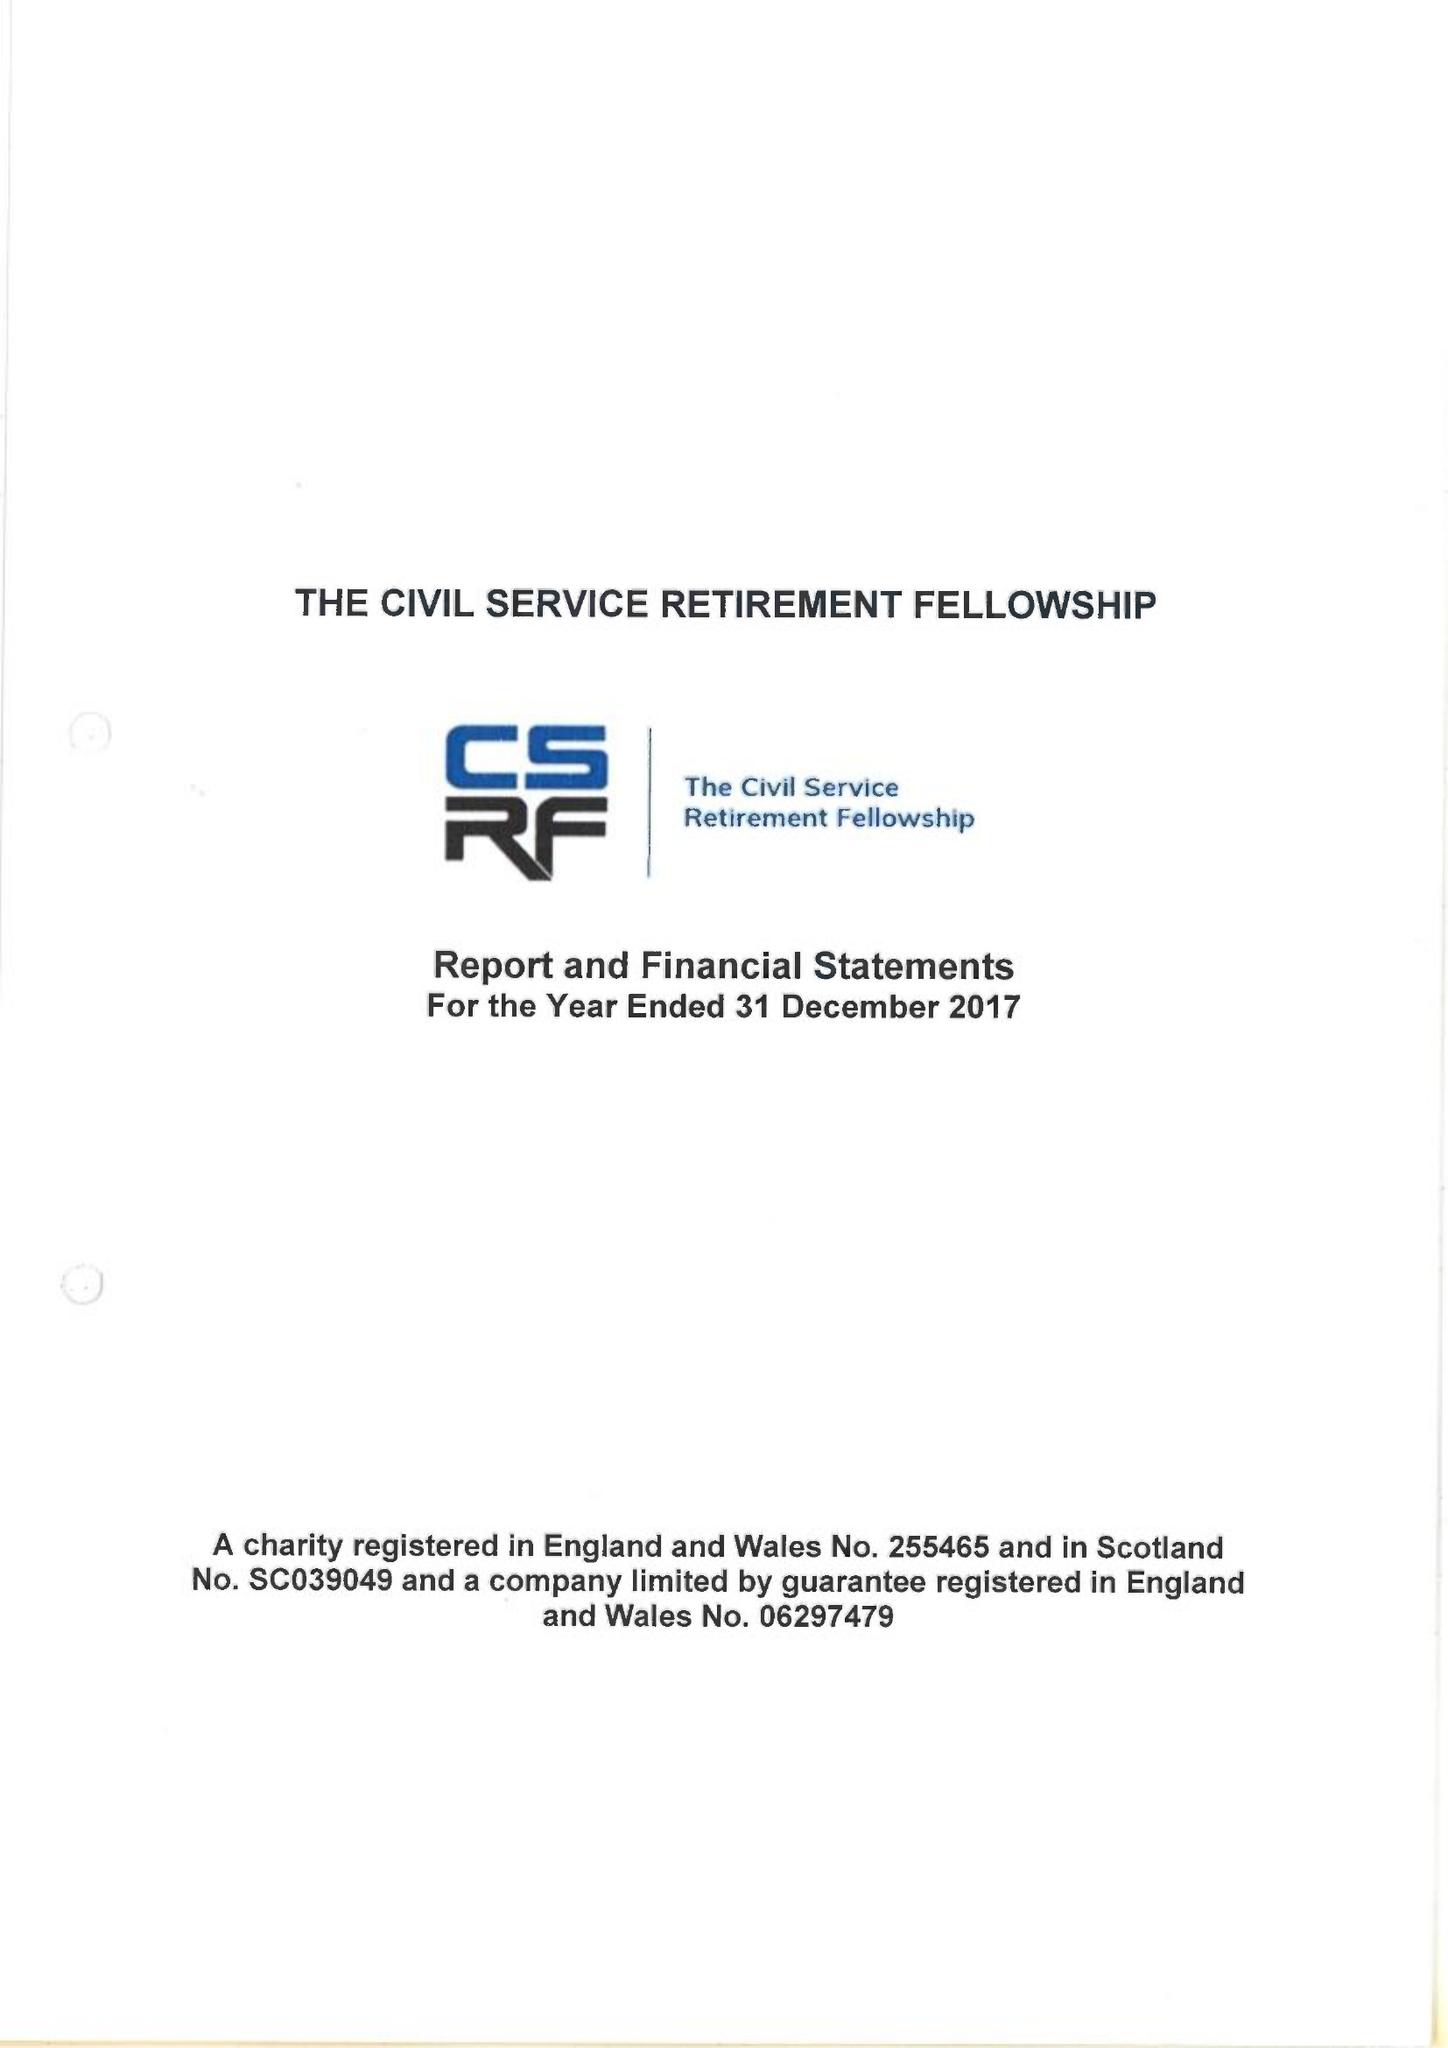What is the value for the income_annually_in_british_pounds?
Answer the question using a single word or phrase. 290584.00 